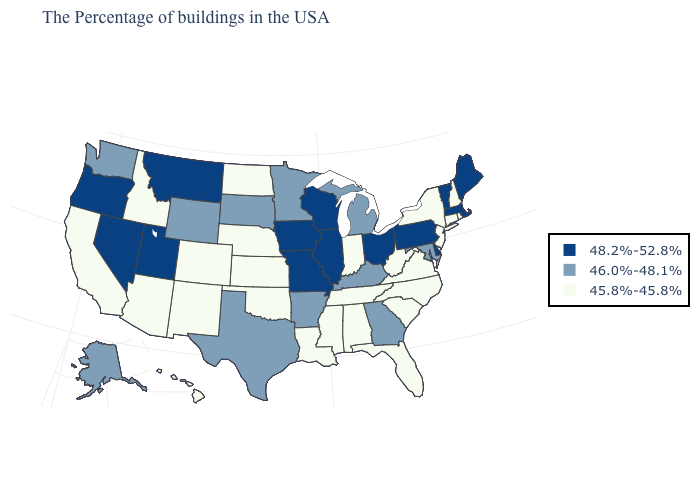Does Kansas have the lowest value in the MidWest?
Give a very brief answer. Yes. What is the value of Wisconsin?
Short answer required. 48.2%-52.8%. Name the states that have a value in the range 46.0%-48.1%?
Quick response, please. Maryland, Georgia, Michigan, Kentucky, Arkansas, Minnesota, Texas, South Dakota, Wyoming, Washington, Alaska. What is the value of Florida?
Write a very short answer. 45.8%-45.8%. Among the states that border Colorado , which have the highest value?
Keep it brief. Utah. Does Utah have the highest value in the USA?
Write a very short answer. Yes. Which states have the lowest value in the USA?
Quick response, please. Rhode Island, New Hampshire, Connecticut, New York, New Jersey, Virginia, North Carolina, South Carolina, West Virginia, Florida, Indiana, Alabama, Tennessee, Mississippi, Louisiana, Kansas, Nebraska, Oklahoma, North Dakota, Colorado, New Mexico, Arizona, Idaho, California, Hawaii. Does the first symbol in the legend represent the smallest category?
Give a very brief answer. No. Does the first symbol in the legend represent the smallest category?
Keep it brief. No. Is the legend a continuous bar?
Be succinct. No. Name the states that have a value in the range 45.8%-45.8%?
Write a very short answer. Rhode Island, New Hampshire, Connecticut, New York, New Jersey, Virginia, North Carolina, South Carolina, West Virginia, Florida, Indiana, Alabama, Tennessee, Mississippi, Louisiana, Kansas, Nebraska, Oklahoma, North Dakota, Colorado, New Mexico, Arizona, Idaho, California, Hawaii. Among the states that border Wisconsin , which have the highest value?
Concise answer only. Illinois, Iowa. Does the first symbol in the legend represent the smallest category?
Quick response, please. No. Name the states that have a value in the range 45.8%-45.8%?
Write a very short answer. Rhode Island, New Hampshire, Connecticut, New York, New Jersey, Virginia, North Carolina, South Carolina, West Virginia, Florida, Indiana, Alabama, Tennessee, Mississippi, Louisiana, Kansas, Nebraska, Oklahoma, North Dakota, Colorado, New Mexico, Arizona, Idaho, California, Hawaii. Name the states that have a value in the range 46.0%-48.1%?
Write a very short answer. Maryland, Georgia, Michigan, Kentucky, Arkansas, Minnesota, Texas, South Dakota, Wyoming, Washington, Alaska. 